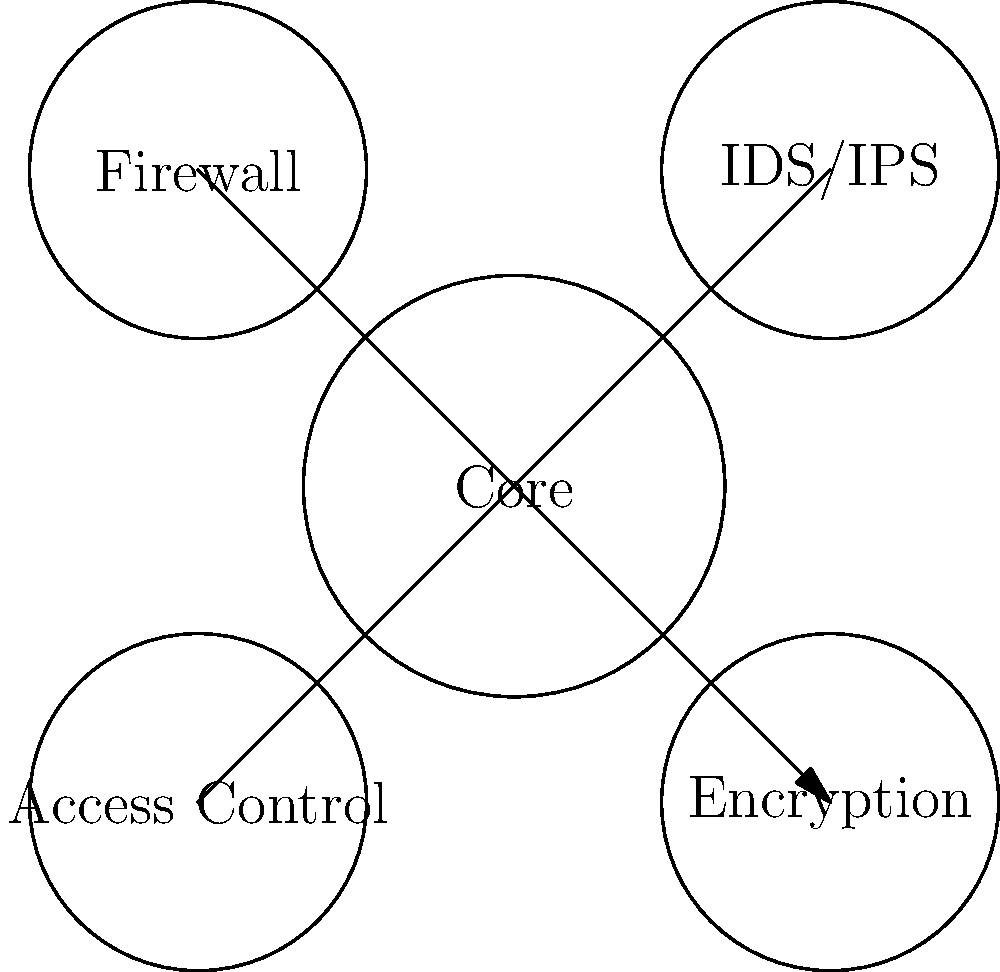In this network security model represented as a martial arts defensive stance, which component acts as the first line of defense against external threats, similar to a fighter's initial blocking technique? To answer this question, let's break down the components of the network security model represented in the martial arts stance:

1. Core: This represents the central system or data that needs protection, similar to a fighter's vital organs.

2. Firewall: Located at the top-left, this is typically the first line of defense in network security. It filters incoming and outgoing traffic based on predetermined security rules.

3. IDS/IPS (Intrusion Detection System/Intrusion Prevention System): Positioned at the top-right, this component monitors network traffic for suspicious activities and can take action to prevent attacks.

4. Access Control: At the bottom-left, this manages user authentication and authorization, controlling who can access the system.

5. Encryption: At the bottom-right, this protects data confidentiality and integrity.

In network security, the firewall is usually the first component to interact with incoming traffic from external sources. It acts as a barrier between trusted internal networks and untrusted external networks (like the Internet).

Similarly, in martial arts, the initial blocking technique is often the first line of defense against an incoming attack. It's designed to stop or deflect the attack before it reaches the fighter's vital areas.

Therefore, the firewall in this model is analogous to the initial blocking technique in martial arts, serving as the first line of defense against external threats.
Answer: Firewall 